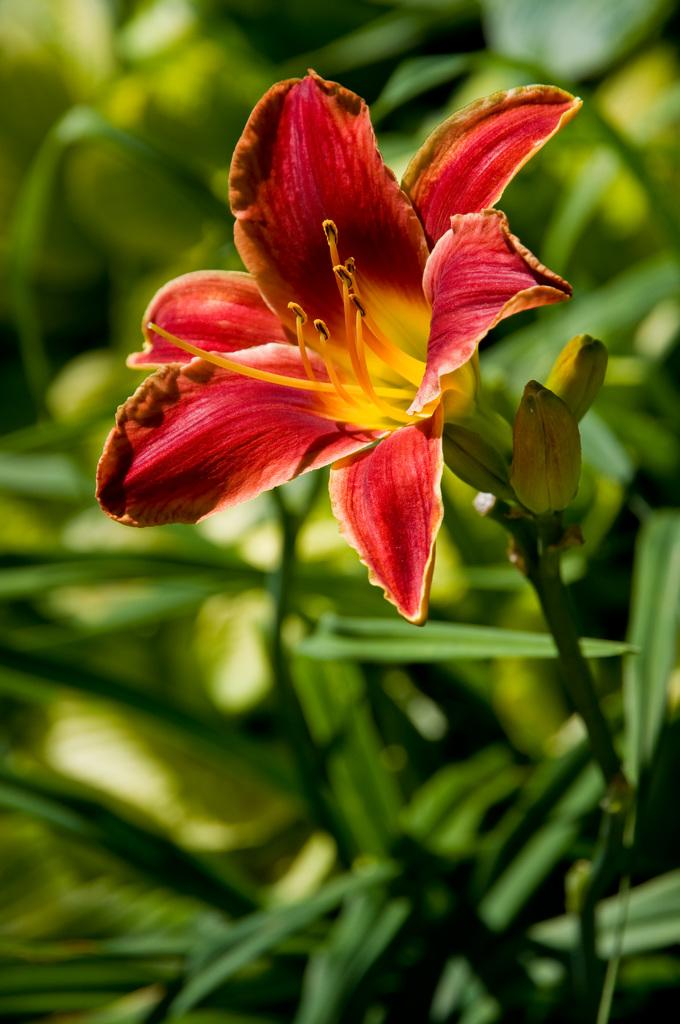What is the main subject of the image? There is a flower in the image. What can be seen in the background of the image? There are leaves in the background of the image. How would you describe the clarity of the image? The image is blurry. What type of boot is being worn by the flower in the image? There is no boot present in the image, as it features a flower and leaves. 